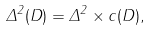<formula> <loc_0><loc_0><loc_500><loc_500>\Delta ^ { 2 } ( D ) = \Delta ^ { 2 } \times c ( D ) ,</formula> 